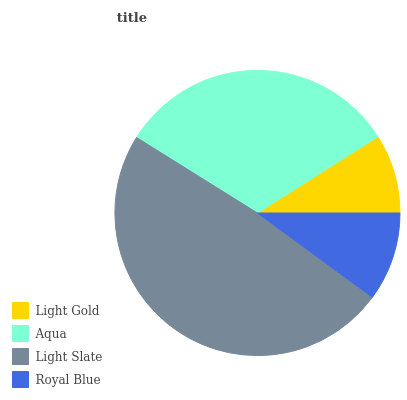Is Light Gold the minimum?
Answer yes or no. Yes. Is Light Slate the maximum?
Answer yes or no. Yes. Is Aqua the minimum?
Answer yes or no. No. Is Aqua the maximum?
Answer yes or no. No. Is Aqua greater than Light Gold?
Answer yes or no. Yes. Is Light Gold less than Aqua?
Answer yes or no. Yes. Is Light Gold greater than Aqua?
Answer yes or no. No. Is Aqua less than Light Gold?
Answer yes or no. No. Is Aqua the high median?
Answer yes or no. Yes. Is Royal Blue the low median?
Answer yes or no. Yes. Is Royal Blue the high median?
Answer yes or no. No. Is Aqua the low median?
Answer yes or no. No. 